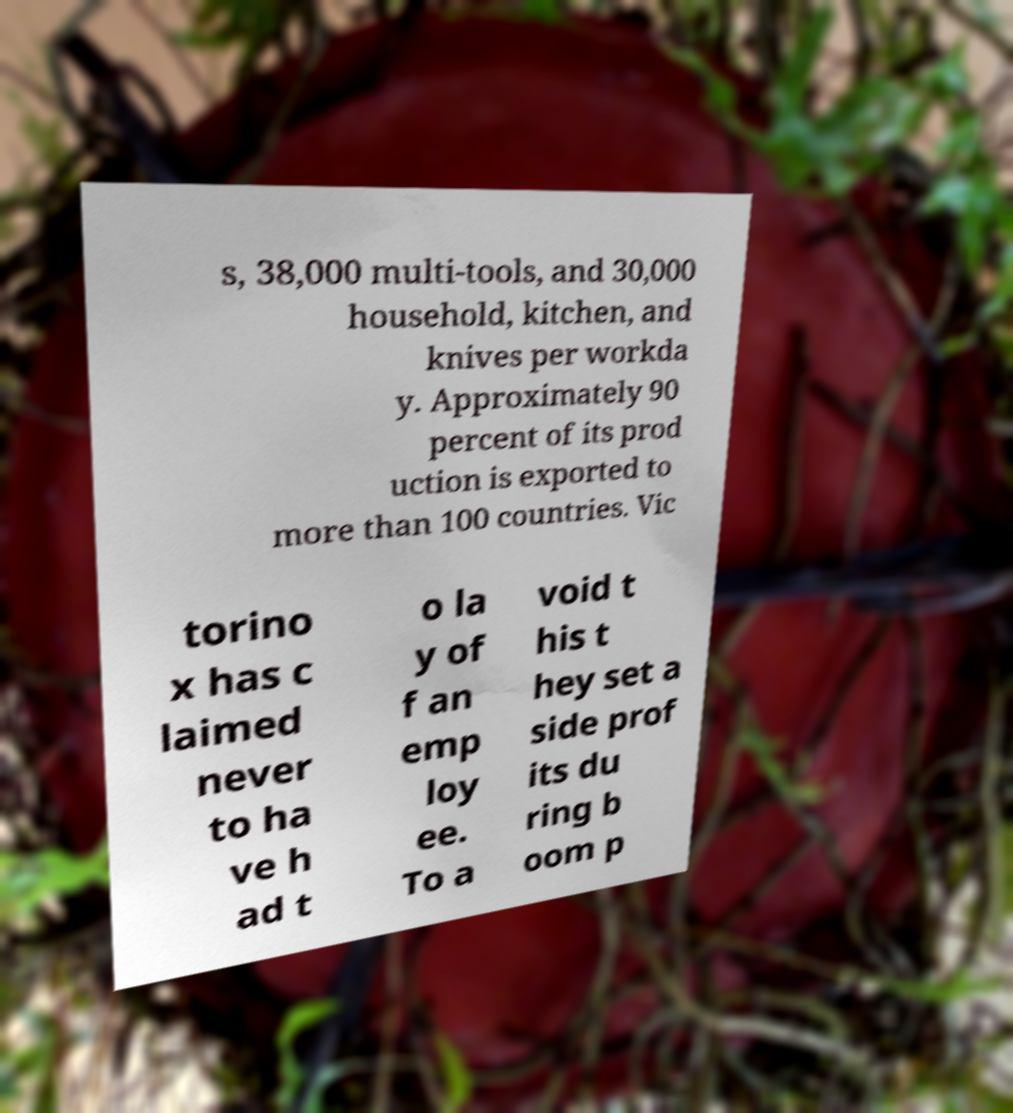Can you read and provide the text displayed in the image?This photo seems to have some interesting text. Can you extract and type it out for me? s, 38,000 multi-tools, and 30,000 household, kitchen, and knives per workda y. Approximately 90 percent of its prod uction is exported to more than 100 countries. Vic torino x has c laimed never to ha ve h ad t o la y of f an emp loy ee. To a void t his t hey set a side prof its du ring b oom p 